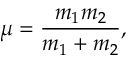Convert formula to latex. <formula><loc_0><loc_0><loc_500><loc_500>\mu = \frac { m _ { 1 } m _ { 2 } } { m _ { 1 } + m _ { 2 } } ,</formula> 